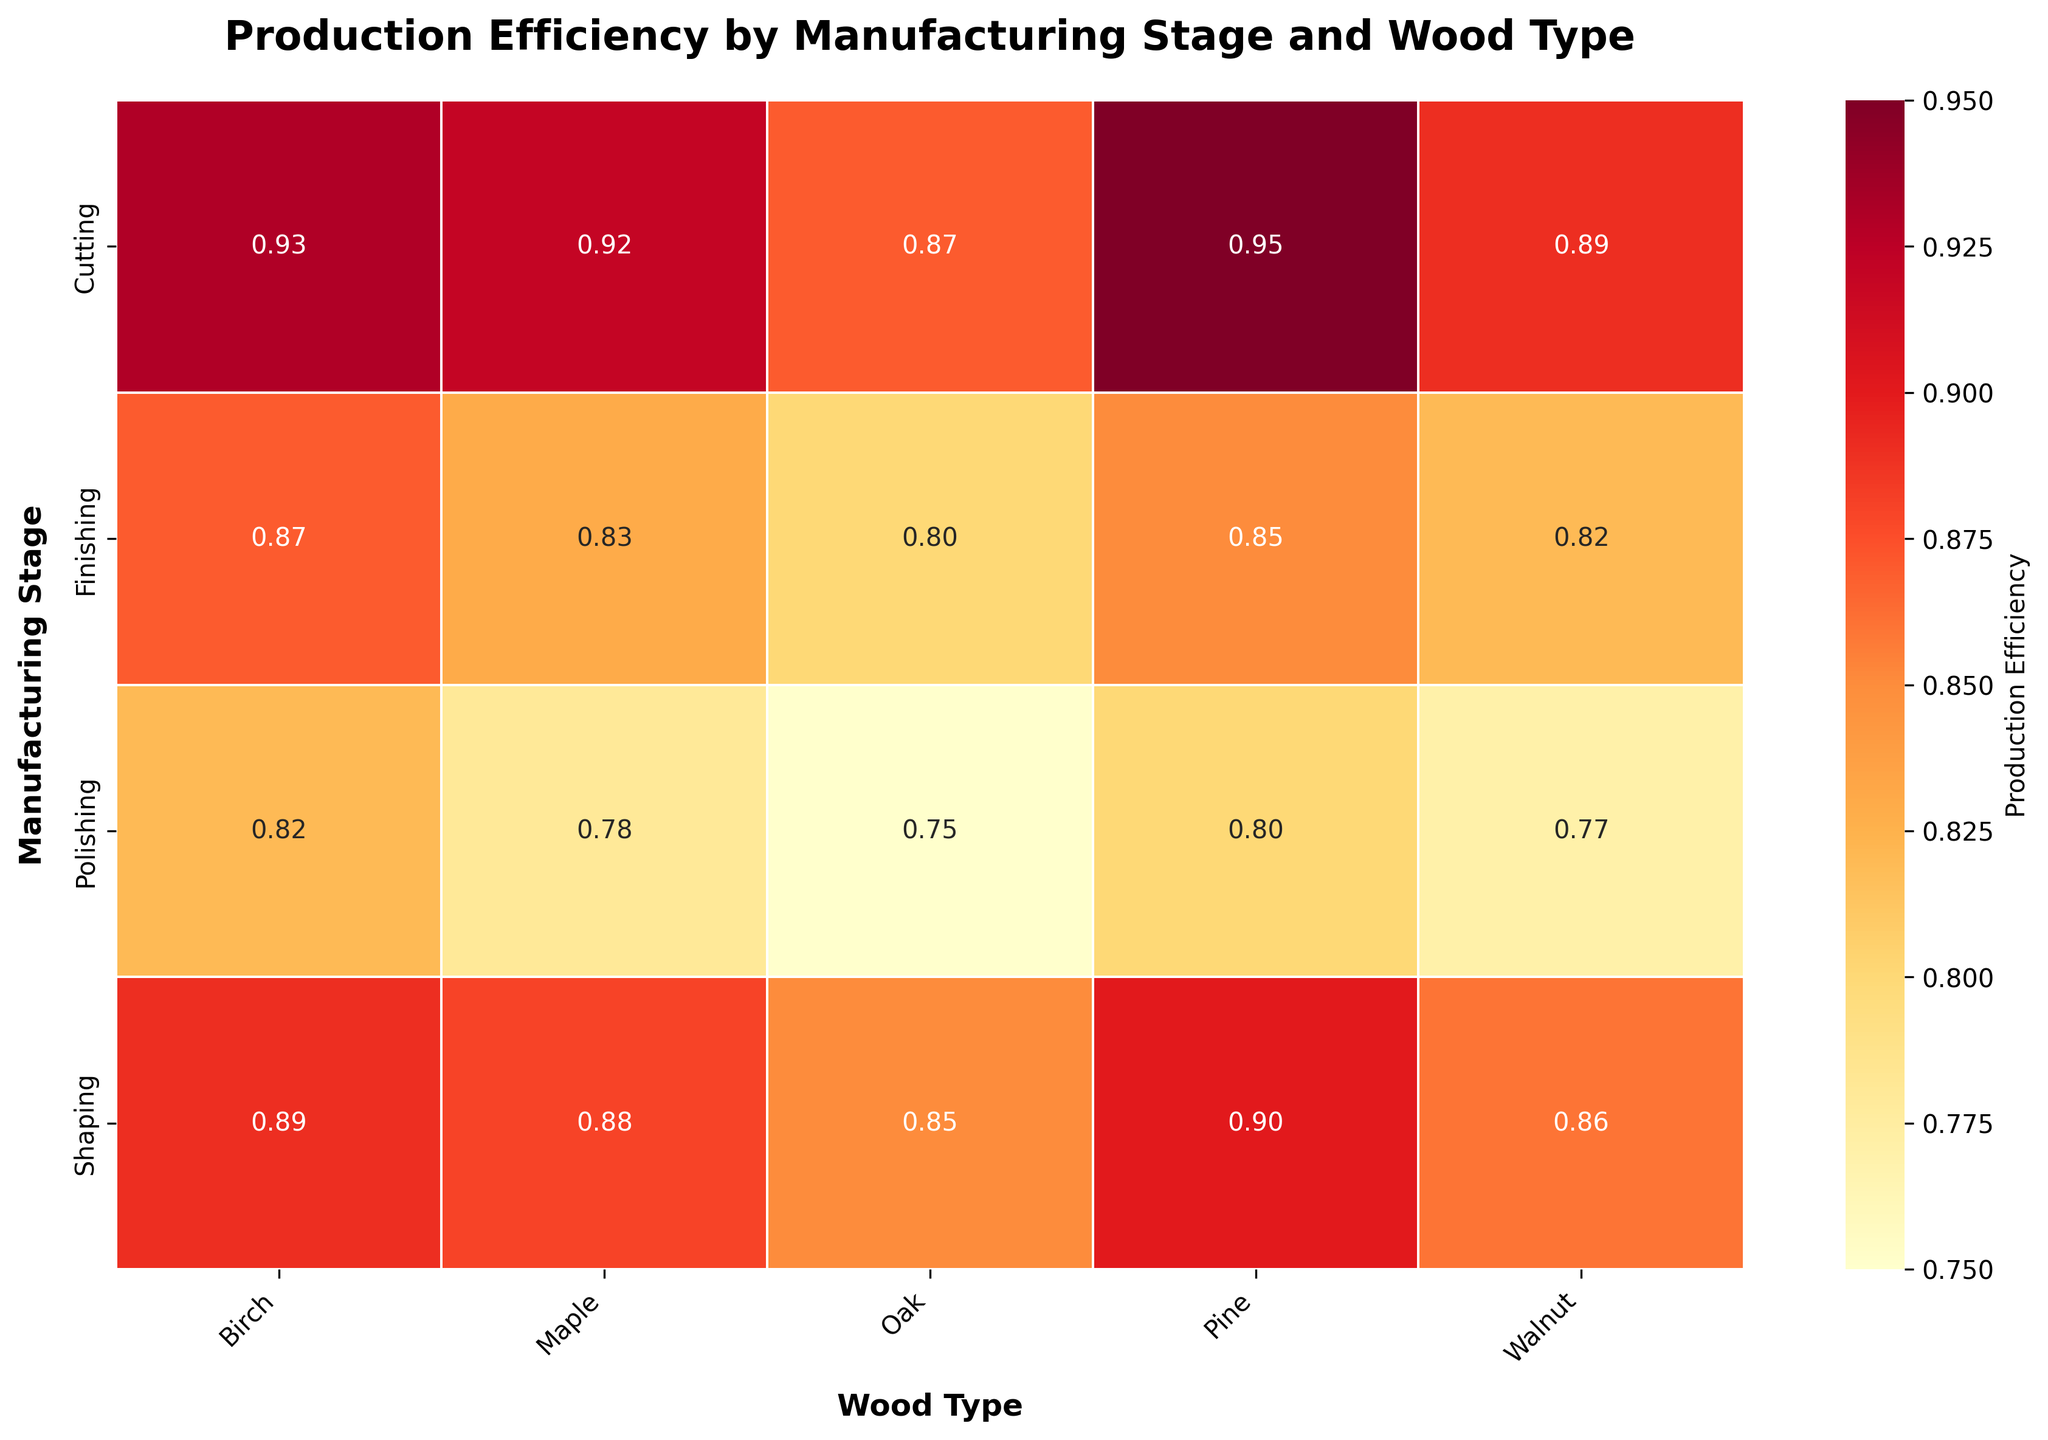What is the title of the heatmap? The title is usually found at the top of the heatmap plot. It describes the main focus of the visualization. In this case, it should indicate both the manufacturing stages and the wood types involved.
Answer: Production Efficiency by Manufacturing Stage and Wood Type Which wood type has the highest production efficiency in the Cutting stage? To find this, look under the column headers for the "Cutting" row. Among the values listed, identify the highest one.
Answer: Pine What is the production efficiency value for Birch in the Polishing stage? Locate the row labeled "Polishing," then move across to the "Birch" column to find the corresponding value.
Answer: 0.82 Which manufacturing stage has the lowest production efficiency for Oak? Search for the values corresponding to "Oak" under each manufacturing stage and identify the lowest value.
Answer: Polishing Calculate the average production efficiency of Maple across all manufacturing stages. To determine this, locate the values for "Maple" in each manufacturing stage, sum them up, and then divide by the number of values. The values are 0.92, 0.88, 0.83, and 0.78. (0.92 + 0.88 + 0.83 + 0.78) / 4 = 3.41 / 4.
Answer: 0.8525 Which wood type consistently appears to have high production efficiency across all stages? Scan the heatmap for the wood type that shows relatively high values (close to 1.00) across each manufacturing stage.
Answer: Pine Compare the production efficiencies of Walnut between Cutting and Shaping stages. Which one is higher? Locate the values for "Walnut" in both "Cutting" and "Shaping" stages and compare them. Cutting has 0.89 and Shaping has 0.86.
Answer: Cutting What trend do you observe in production efficiency from Cutting to Polishing for Oak? Note the values for "Oak" across the manufacturing stages of Cutting, Shaping, Finishing, and Polishing, and describe the pattern. The values decline from 0.87 to 0.75.
Answer: Decreasing trend Which manufacturing stage shows the most consistent production efficiency across all wood types? Examine the rows corresponding to each manufacturing stage and note the variation in values. The stage with the smallest variation or most similar values is the most consistent.
Answer: Cutting 